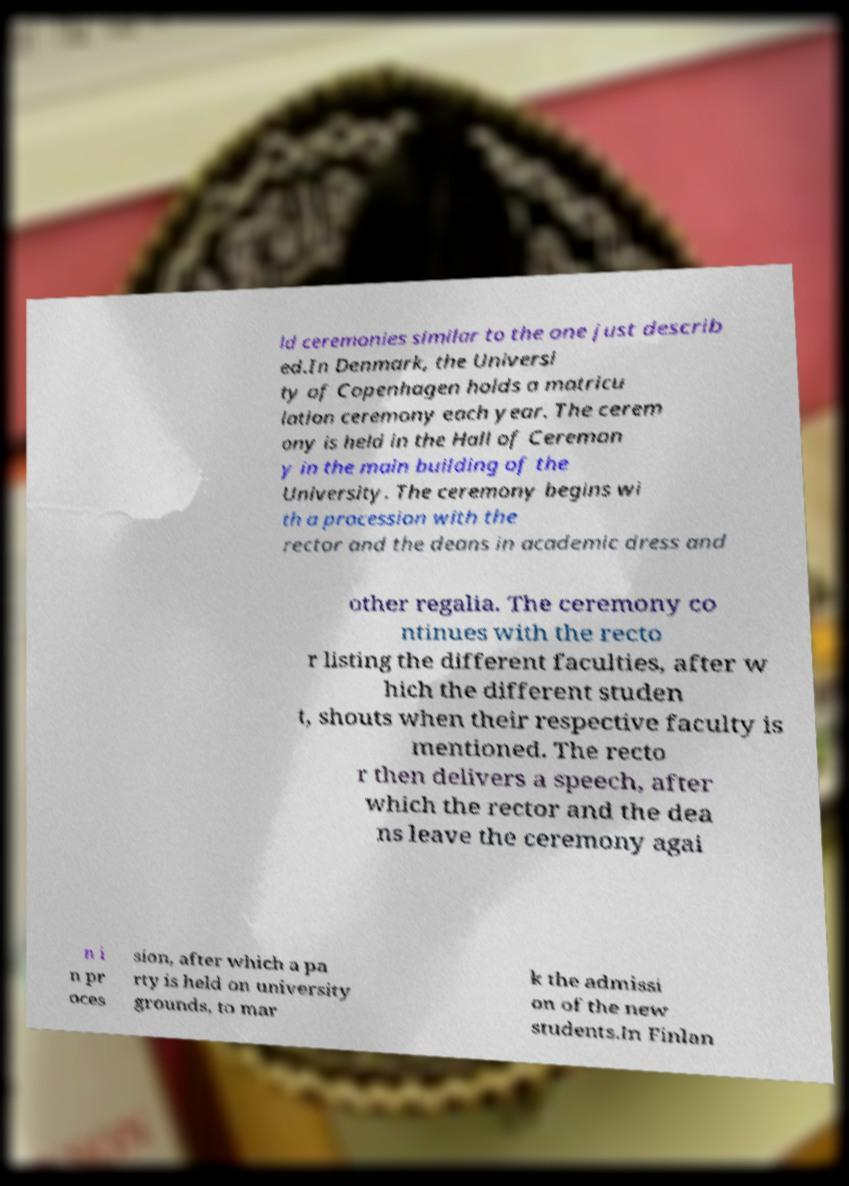Can you accurately transcribe the text from the provided image for me? ld ceremonies similar to the one just describ ed.In Denmark, the Universi ty of Copenhagen holds a matricu lation ceremony each year. The cerem ony is held in the Hall of Ceremon y in the main building of the University. The ceremony begins wi th a procession with the rector and the deans in academic dress and other regalia. The ceremony co ntinues with the recto r listing the different faculties, after w hich the different studen t, shouts when their respective faculty is mentioned. The recto r then delivers a speech, after which the rector and the dea ns leave the ceremony agai n i n pr oces sion, after which a pa rty is held on university grounds, to mar k the admissi on of the new students.In Finlan 